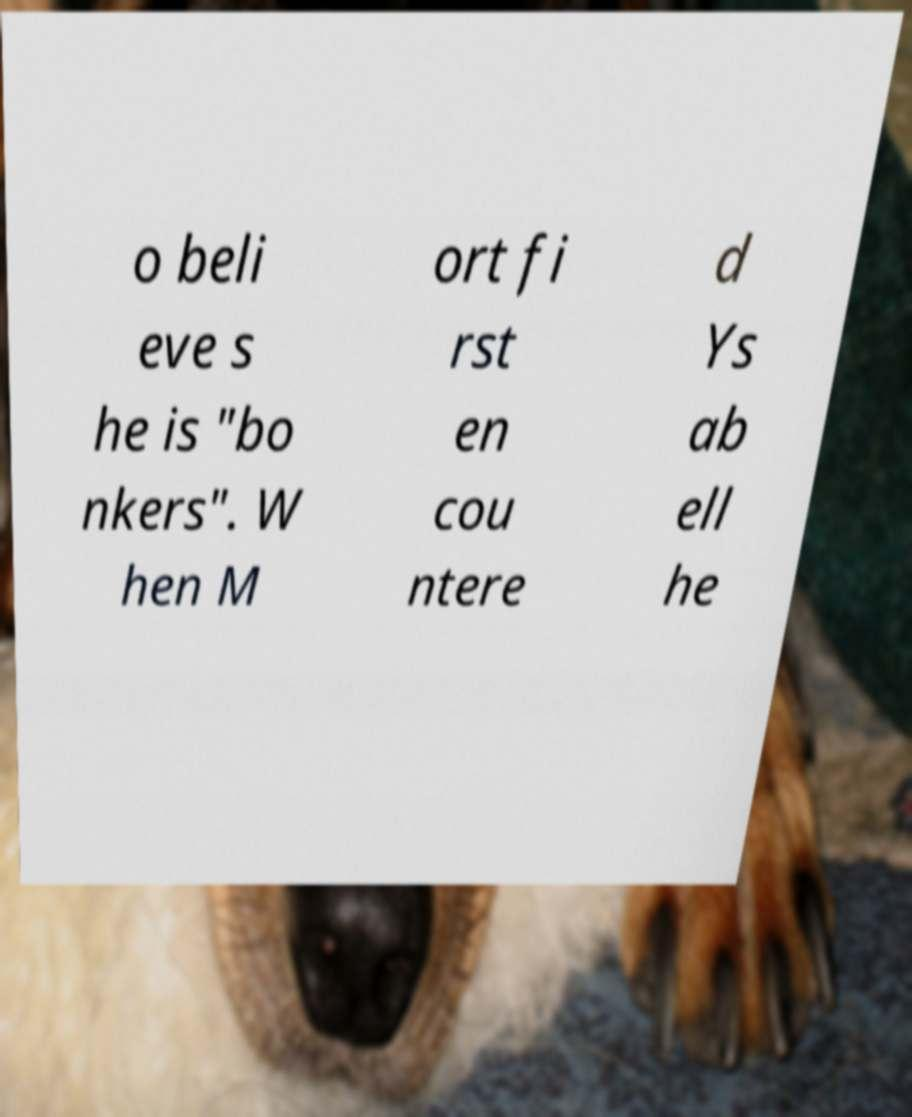Can you accurately transcribe the text from the provided image for me? o beli eve s he is "bo nkers". W hen M ort fi rst en cou ntere d Ys ab ell he 